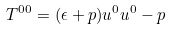<formula> <loc_0><loc_0><loc_500><loc_500>T ^ { 0 0 } = ( \epsilon + p ) u ^ { 0 } u ^ { 0 } - p</formula> 